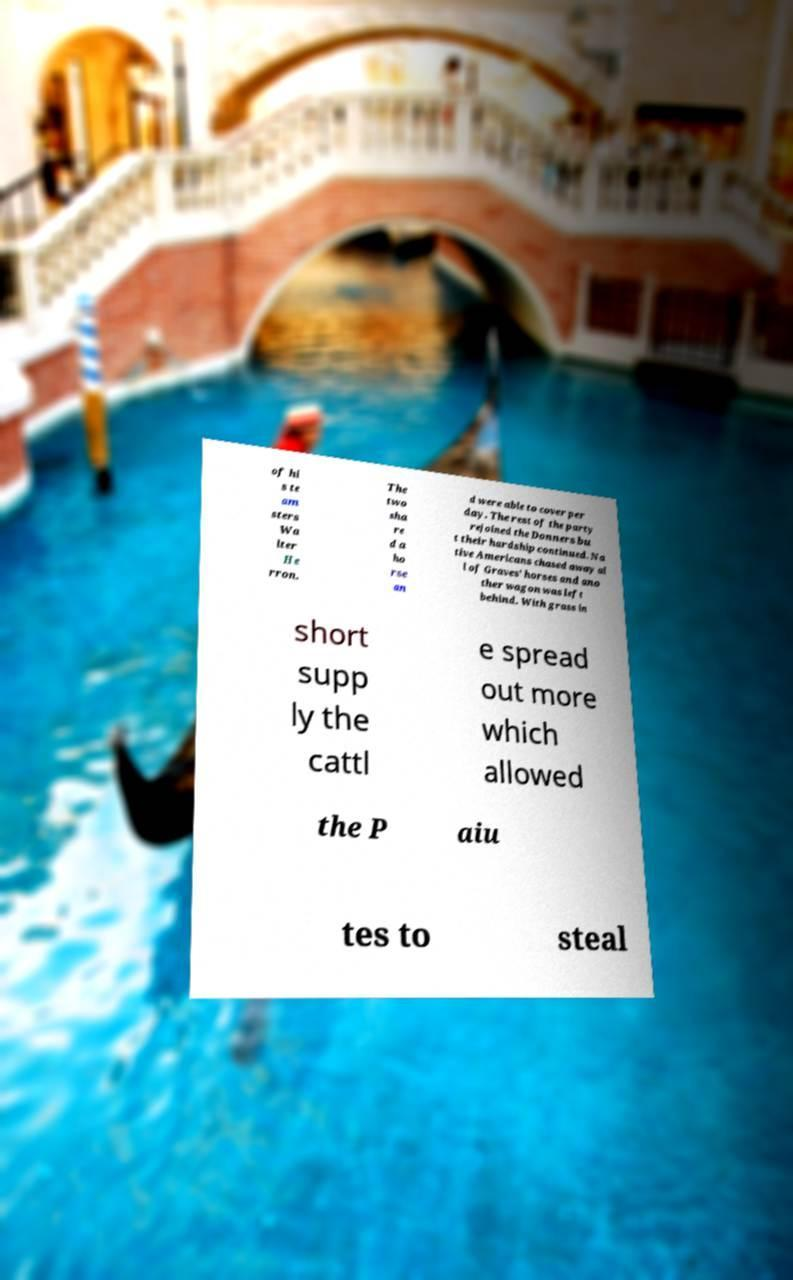I need the written content from this picture converted into text. Can you do that? of hi s te am sters Wa lter He rron. The two sha re d a ho rse an d were able to cover per day. The rest of the party rejoined the Donners bu t their hardship continued. Na tive Americans chased away al l of Graves' horses and ano ther wagon was left behind. With grass in short supp ly the cattl e spread out more which allowed the P aiu tes to steal 